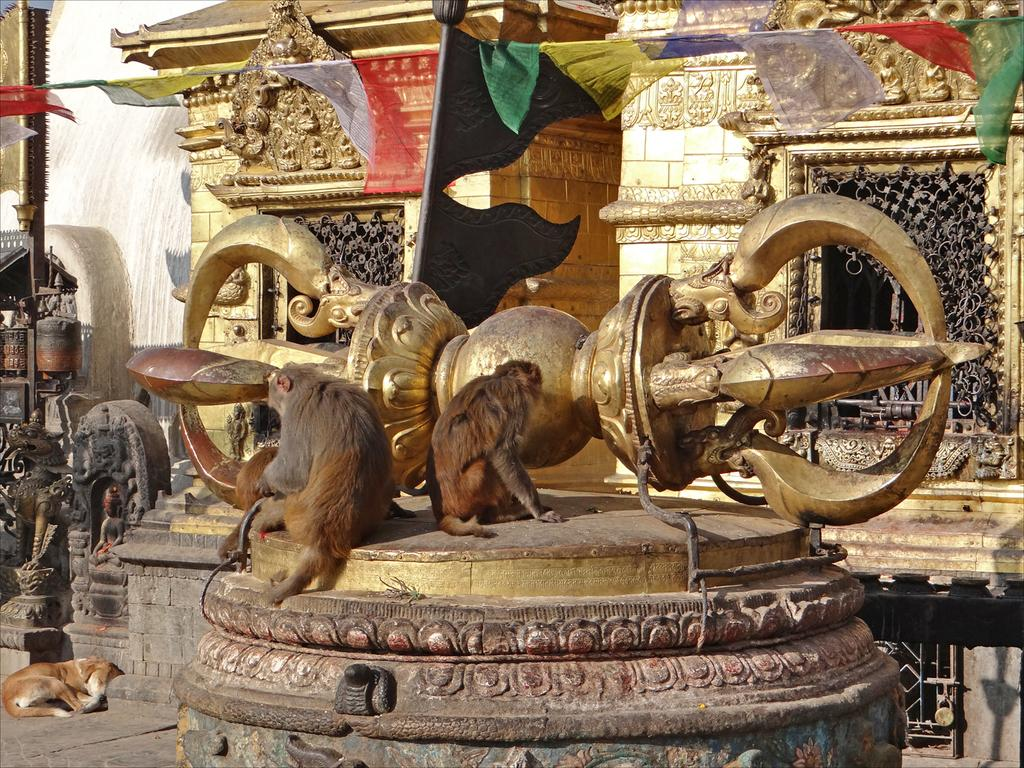How many monkeys are in the image? There are two monkeys in the image. Where are the monkeys located? The monkeys are on a pillar in the image. On which side of the image is the pillar? The pillar is on the left side of the image. What other animal can be seen in the image? There is a dog in the image. What is the dog doing in the image? The dog is sleeping on the floor in the image. What holiday is being celebrated in the image? There is no indication of a holiday being celebrated in the image. What theory is being discussed by the monkeys in the image? There is no discussion or theory present in the image; the monkeys are simply on a pillar. 